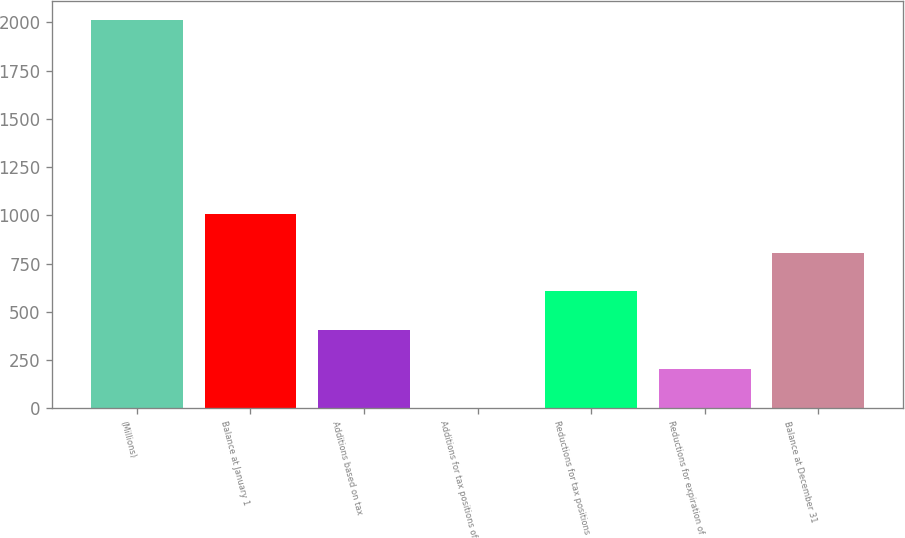<chart> <loc_0><loc_0><loc_500><loc_500><bar_chart><fcel>(Millions)<fcel>Balance at January 1<fcel>Additions based on tax<fcel>Additions for tax positions of<fcel>Reductions for tax positions<fcel>Reductions for expiration of<fcel>Balance at December 31<nl><fcel>2012<fcel>1007<fcel>404<fcel>2<fcel>605<fcel>203<fcel>806<nl></chart> 